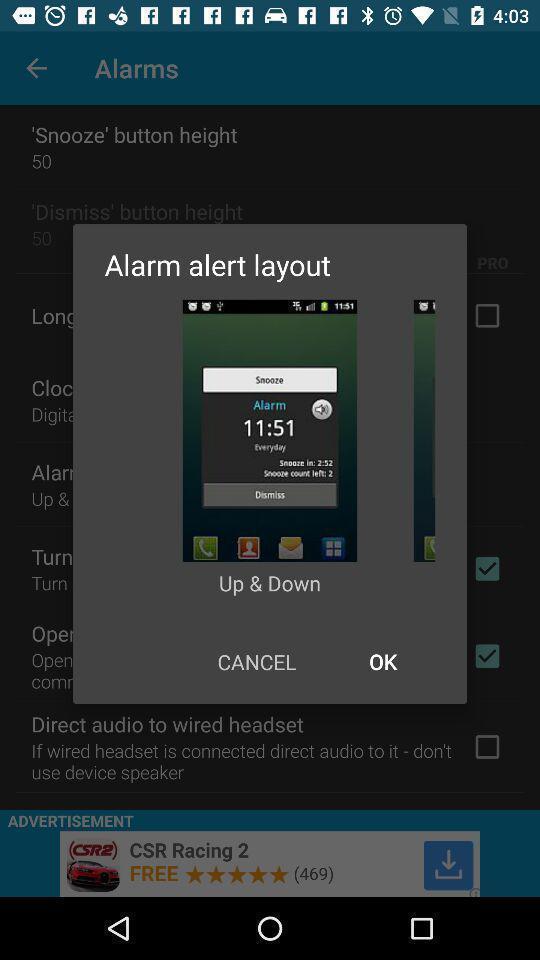Give me a narrative description of this picture. Pop-up showing an alarm alert message. 